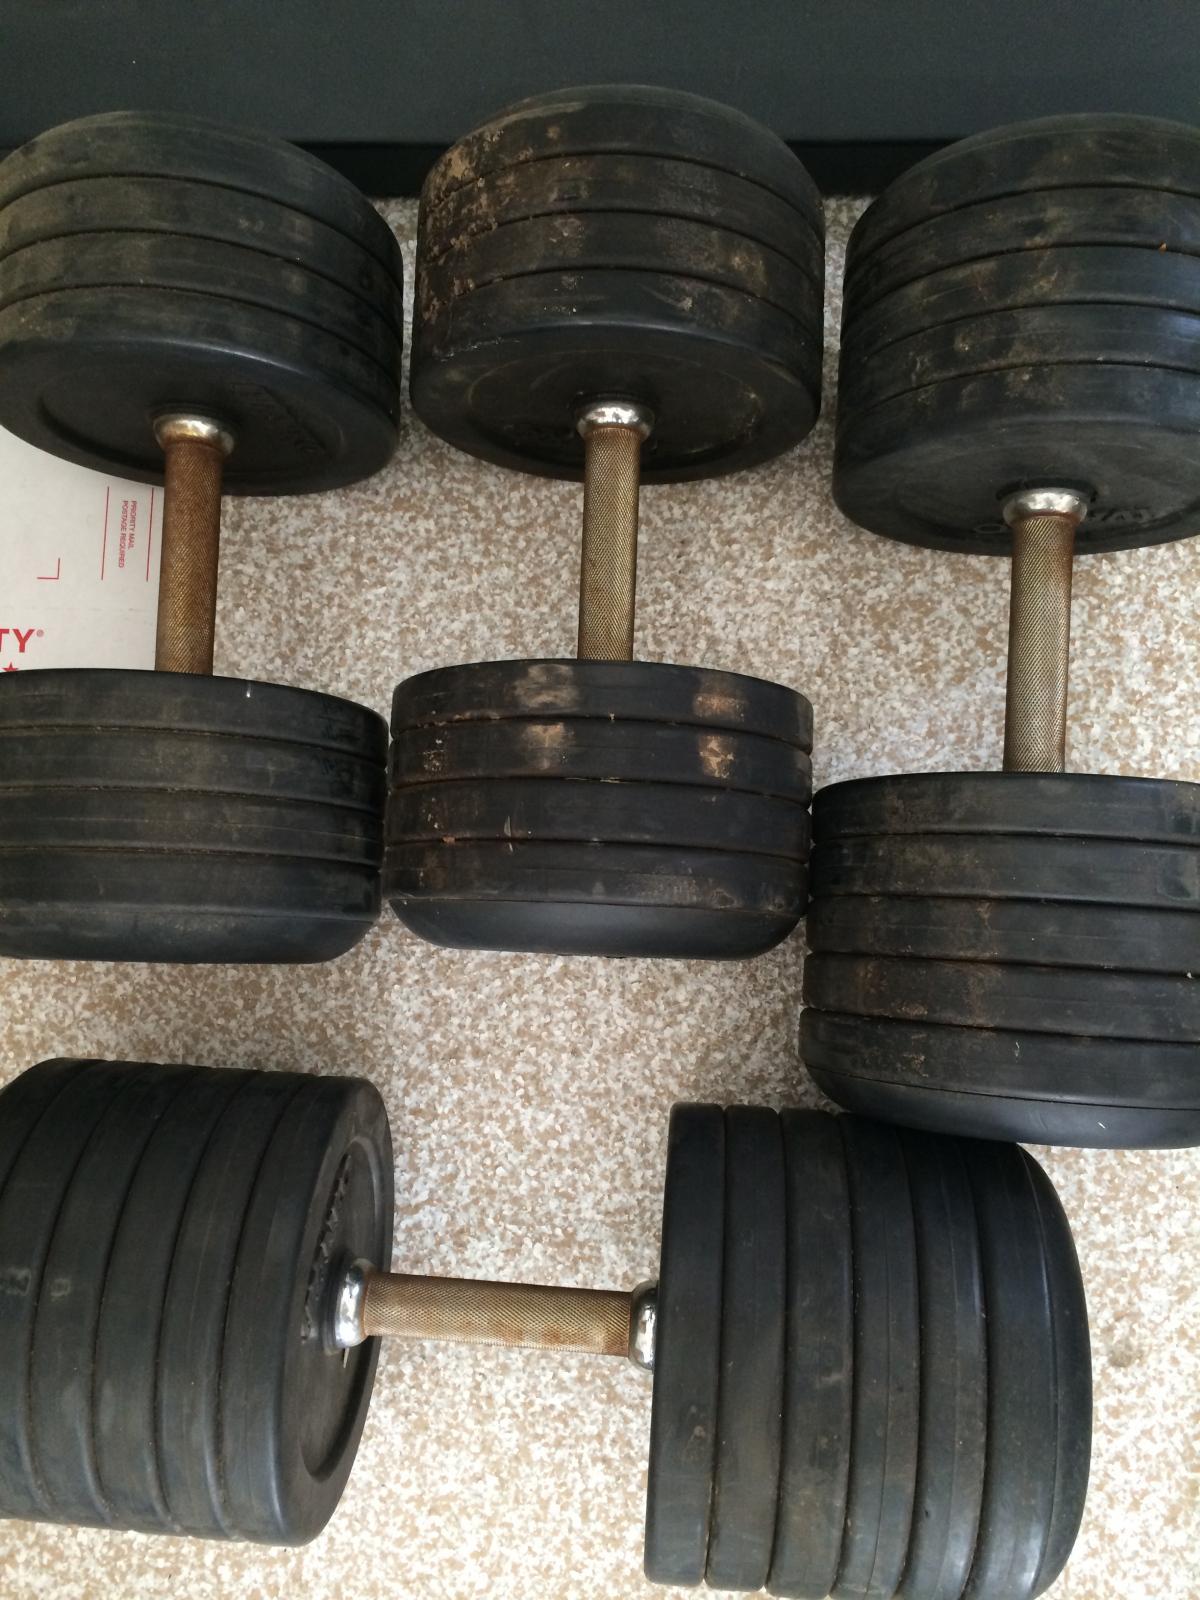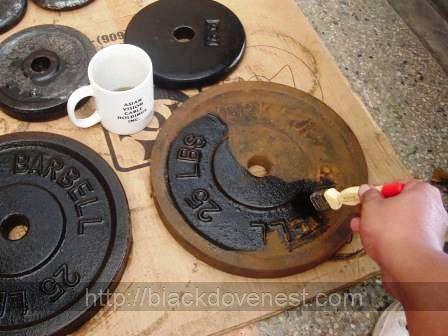The first image is the image on the left, the second image is the image on the right. Evaluate the accuracy of this statement regarding the images: "There are exactly four objects.". Is it true? Answer yes or no. No. The first image is the image on the left, the second image is the image on the right. For the images displayed, is the sentence "One of the weights has tarnished brown surfaces." factually correct? Answer yes or no. Yes. 